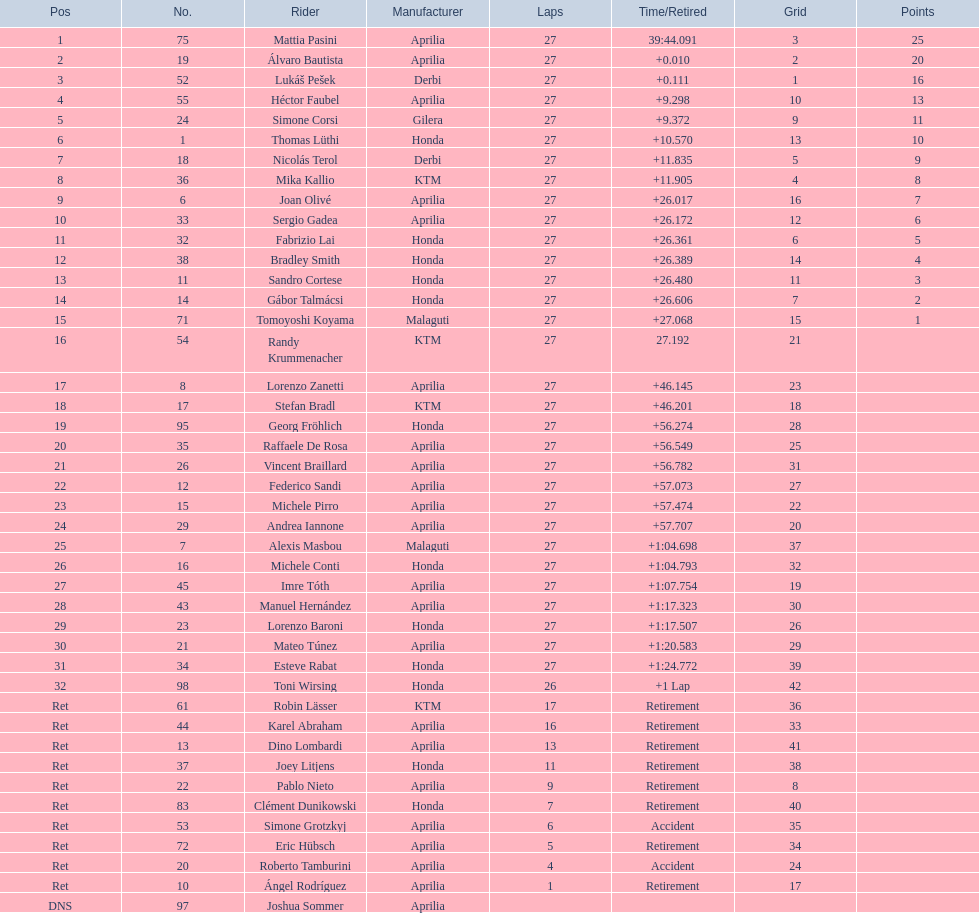How many german racers finished the race? 4. 